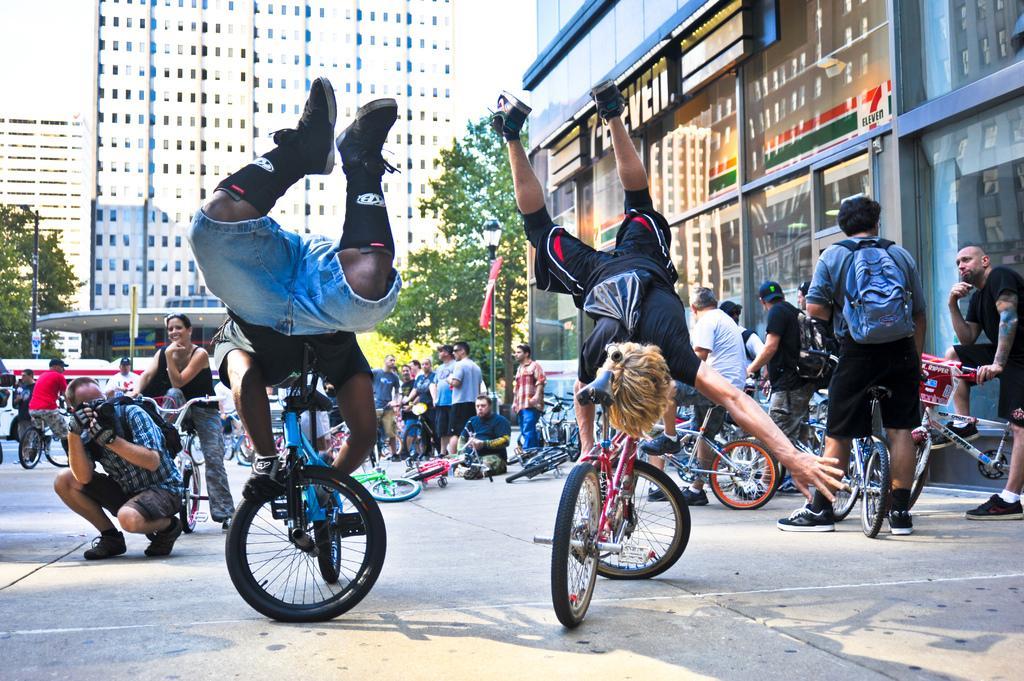Describe this image in one or two sentences. In this picture we can see some people standing in the background, there are some bicycles here, this person is carrying a bag, a man on the left side is holding a camera, in the background there are some buildings, we can see trees here, there is a pole here. 